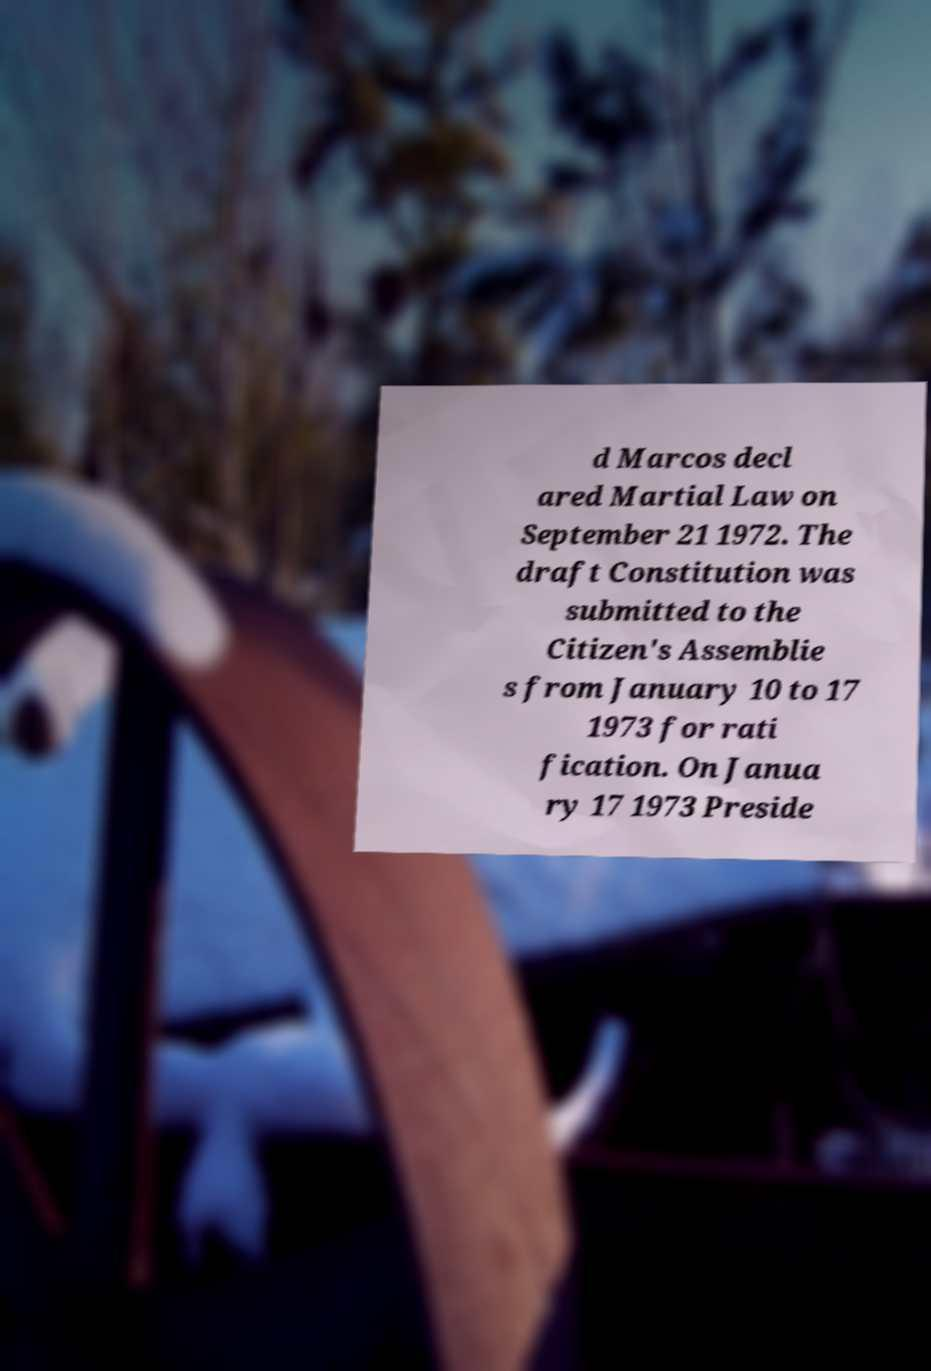I need the written content from this picture converted into text. Can you do that? d Marcos decl ared Martial Law on September 21 1972. The draft Constitution was submitted to the Citizen's Assemblie s from January 10 to 17 1973 for rati fication. On Janua ry 17 1973 Preside 